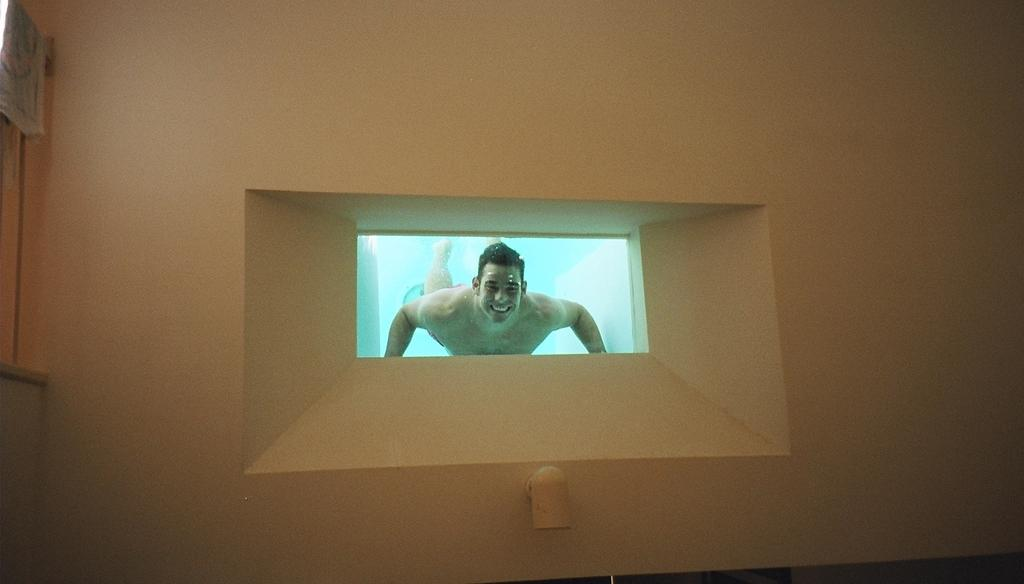Who is present in the image? There is a man in the image. What is the man doing in the image? The man is swimming in the water and laughing. How can the man be seen in the image? The man is visible from a window. Where is the window located in the image? The window is on a wall. What is the man attempting to do with his eye in the image? There is no mention of the man attempting to do anything with his eye in the image. 